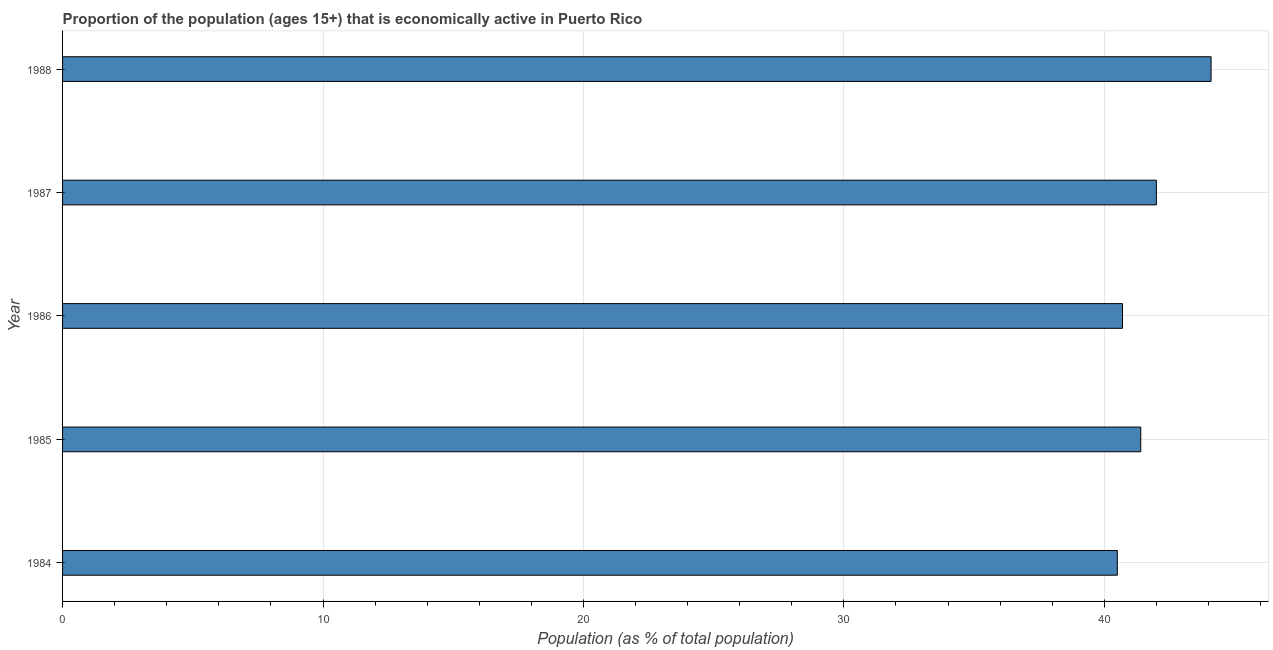What is the title of the graph?
Provide a succinct answer. Proportion of the population (ages 15+) that is economically active in Puerto Rico. What is the label or title of the X-axis?
Give a very brief answer. Population (as % of total population). What is the label or title of the Y-axis?
Make the answer very short. Year. What is the percentage of economically active population in 1985?
Offer a terse response. 41.4. Across all years, what is the maximum percentage of economically active population?
Make the answer very short. 44.1. Across all years, what is the minimum percentage of economically active population?
Your answer should be very brief. 40.5. In which year was the percentage of economically active population maximum?
Give a very brief answer. 1988. What is the sum of the percentage of economically active population?
Ensure brevity in your answer.  208.7. What is the difference between the percentage of economically active population in 1986 and 1988?
Your answer should be compact. -3.4. What is the average percentage of economically active population per year?
Your response must be concise. 41.74. What is the median percentage of economically active population?
Your response must be concise. 41.4. Do a majority of the years between 1987 and 1988 (inclusive) have percentage of economically active population greater than 42 %?
Offer a very short reply. No. Is the percentage of economically active population in 1984 less than that in 1988?
Provide a short and direct response. Yes. Are all the bars in the graph horizontal?
Provide a succinct answer. Yes. Are the values on the major ticks of X-axis written in scientific E-notation?
Ensure brevity in your answer.  No. What is the Population (as % of total population) of 1984?
Provide a short and direct response. 40.5. What is the Population (as % of total population) of 1985?
Give a very brief answer. 41.4. What is the Population (as % of total population) of 1986?
Your answer should be compact. 40.7. What is the Population (as % of total population) in 1987?
Provide a succinct answer. 42. What is the Population (as % of total population) in 1988?
Provide a succinct answer. 44.1. What is the difference between the Population (as % of total population) in 1984 and 1987?
Offer a very short reply. -1.5. What is the difference between the Population (as % of total population) in 1986 and 1987?
Give a very brief answer. -1.3. What is the ratio of the Population (as % of total population) in 1984 to that in 1985?
Offer a very short reply. 0.98. What is the ratio of the Population (as % of total population) in 1984 to that in 1987?
Your response must be concise. 0.96. What is the ratio of the Population (as % of total population) in 1984 to that in 1988?
Give a very brief answer. 0.92. What is the ratio of the Population (as % of total population) in 1985 to that in 1986?
Keep it short and to the point. 1.02. What is the ratio of the Population (as % of total population) in 1985 to that in 1987?
Provide a succinct answer. 0.99. What is the ratio of the Population (as % of total population) in 1985 to that in 1988?
Your answer should be compact. 0.94. What is the ratio of the Population (as % of total population) in 1986 to that in 1988?
Ensure brevity in your answer.  0.92. What is the ratio of the Population (as % of total population) in 1987 to that in 1988?
Provide a short and direct response. 0.95. 